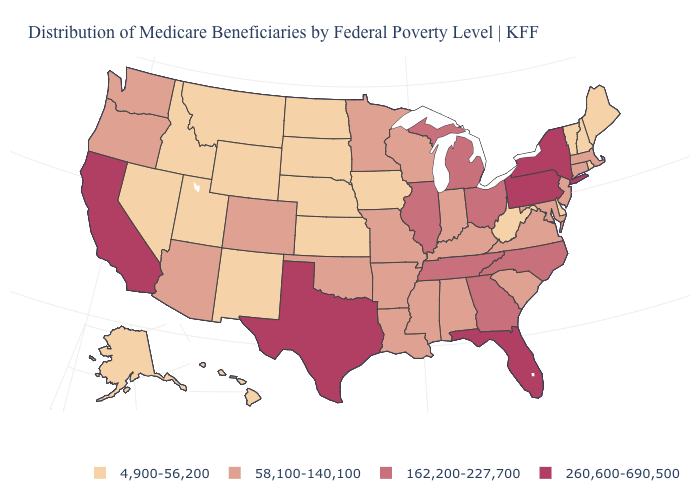Is the legend a continuous bar?
Answer briefly. No. Is the legend a continuous bar?
Give a very brief answer. No. What is the value of Michigan?
Answer briefly. 162,200-227,700. Name the states that have a value in the range 58,100-140,100?
Quick response, please. Alabama, Arizona, Arkansas, Colorado, Connecticut, Indiana, Kentucky, Louisiana, Maryland, Massachusetts, Minnesota, Mississippi, Missouri, New Jersey, Oklahoma, Oregon, South Carolina, Virginia, Washington, Wisconsin. What is the value of Colorado?
Write a very short answer. 58,100-140,100. Name the states that have a value in the range 162,200-227,700?
Be succinct. Georgia, Illinois, Michigan, North Carolina, Ohio, Tennessee. What is the highest value in the Northeast ?
Quick response, please. 260,600-690,500. Name the states that have a value in the range 4,900-56,200?
Concise answer only. Alaska, Delaware, Hawaii, Idaho, Iowa, Kansas, Maine, Montana, Nebraska, Nevada, New Hampshire, New Mexico, North Dakota, Rhode Island, South Dakota, Utah, Vermont, West Virginia, Wyoming. What is the value of Ohio?
Keep it brief. 162,200-227,700. What is the value of New Jersey?
Quick response, please. 58,100-140,100. What is the value of Tennessee?
Give a very brief answer. 162,200-227,700. Does Georgia have a lower value than New York?
Keep it brief. Yes. What is the value of North Dakota?
Keep it brief. 4,900-56,200. What is the value of Nevada?
Write a very short answer. 4,900-56,200. Which states have the highest value in the USA?
Concise answer only. California, Florida, New York, Pennsylvania, Texas. 